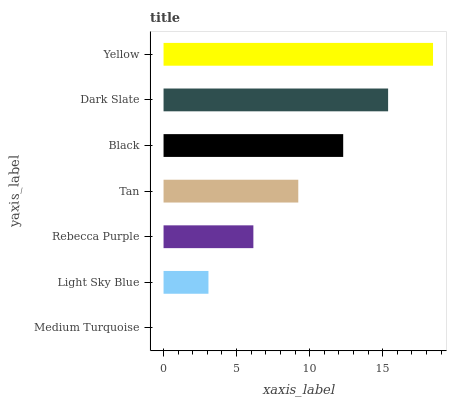Is Medium Turquoise the minimum?
Answer yes or no. Yes. Is Yellow the maximum?
Answer yes or no. Yes. Is Light Sky Blue the minimum?
Answer yes or no. No. Is Light Sky Blue the maximum?
Answer yes or no. No. Is Light Sky Blue greater than Medium Turquoise?
Answer yes or no. Yes. Is Medium Turquoise less than Light Sky Blue?
Answer yes or no. Yes. Is Medium Turquoise greater than Light Sky Blue?
Answer yes or no. No. Is Light Sky Blue less than Medium Turquoise?
Answer yes or no. No. Is Tan the high median?
Answer yes or no. Yes. Is Tan the low median?
Answer yes or no. Yes. Is Medium Turquoise the high median?
Answer yes or no. No. Is Black the low median?
Answer yes or no. No. 